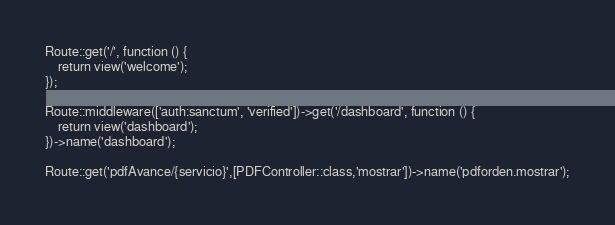Convert code to text. <code><loc_0><loc_0><loc_500><loc_500><_PHP_>
Route::get('/', function () {
    return view('welcome');
});

Route::middleware(['auth:sanctum', 'verified'])->get('/dashboard', function () {
    return view('dashboard');
})->name('dashboard');

Route::get('pdfAvance/{servicio}',[PDFController::class,'mostrar'])->name('pdforden.mostrar');

</code> 